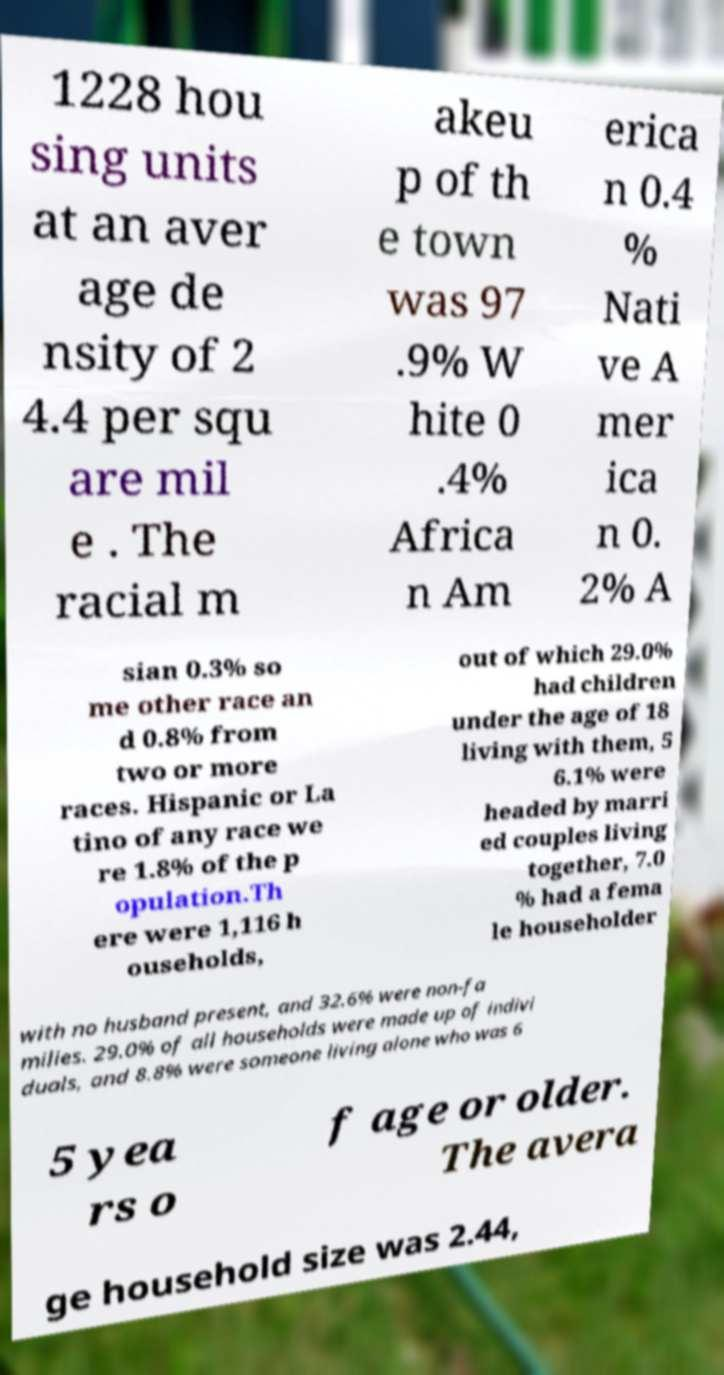Could you extract and type out the text from this image? 1228 hou sing units at an aver age de nsity of 2 4.4 per squ are mil e . The racial m akeu p of th e town was 97 .9% W hite 0 .4% Africa n Am erica n 0.4 % Nati ve A mer ica n 0. 2% A sian 0.3% so me other race an d 0.8% from two or more races. Hispanic or La tino of any race we re 1.8% of the p opulation.Th ere were 1,116 h ouseholds, out of which 29.0% had children under the age of 18 living with them, 5 6.1% were headed by marri ed couples living together, 7.0 % had a fema le householder with no husband present, and 32.6% were non-fa milies. 29.0% of all households were made up of indivi duals, and 8.8% were someone living alone who was 6 5 yea rs o f age or older. The avera ge household size was 2.44, 